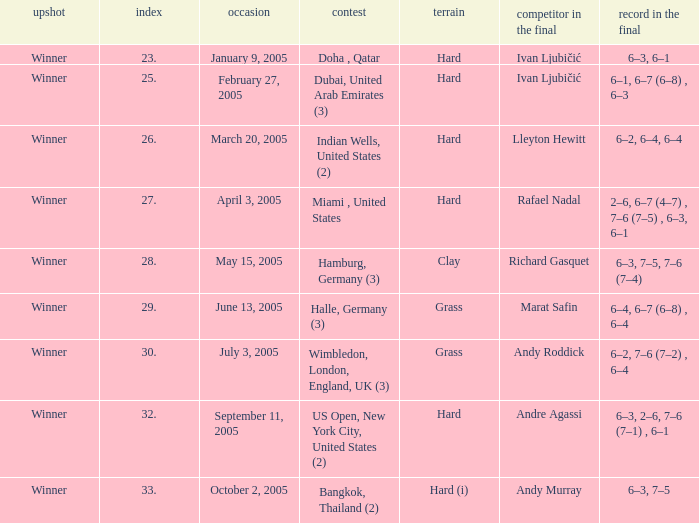Andy Roddick is the opponent in the final on what surface? Grass. 